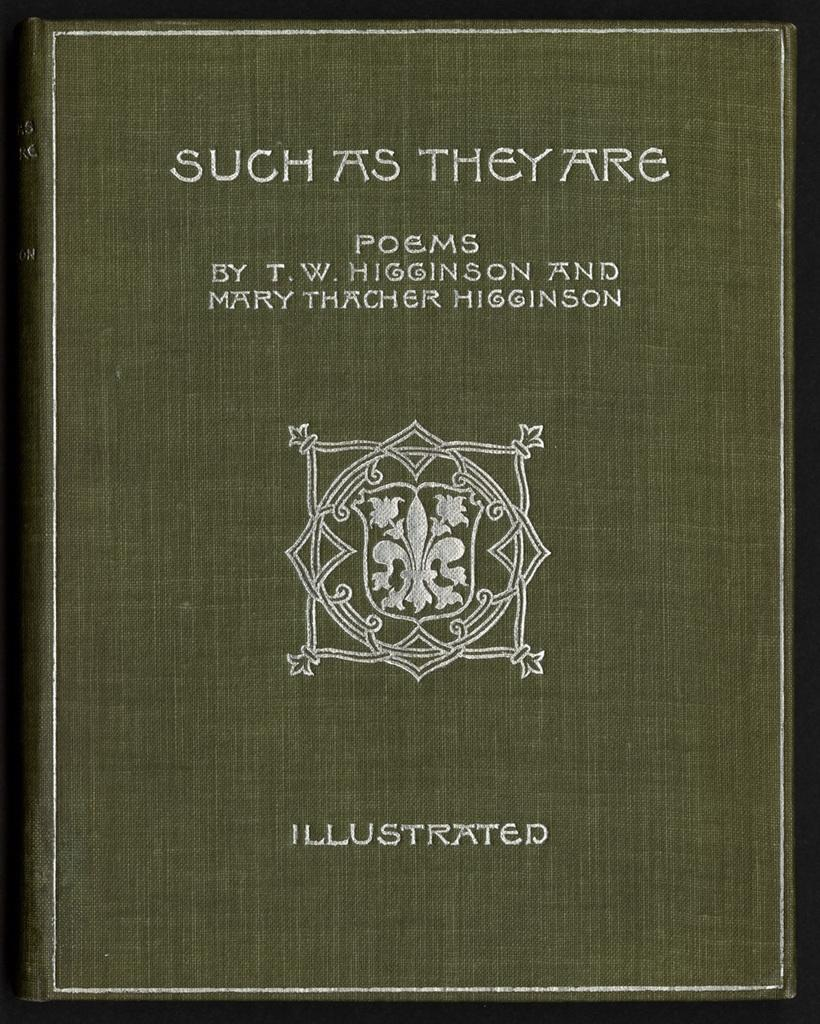Provide a one-sentence caption for the provided image. The collection of poems by T.W. Higginson and Mary Thatcher Higginson, "Such as They Are", is illustrated. 